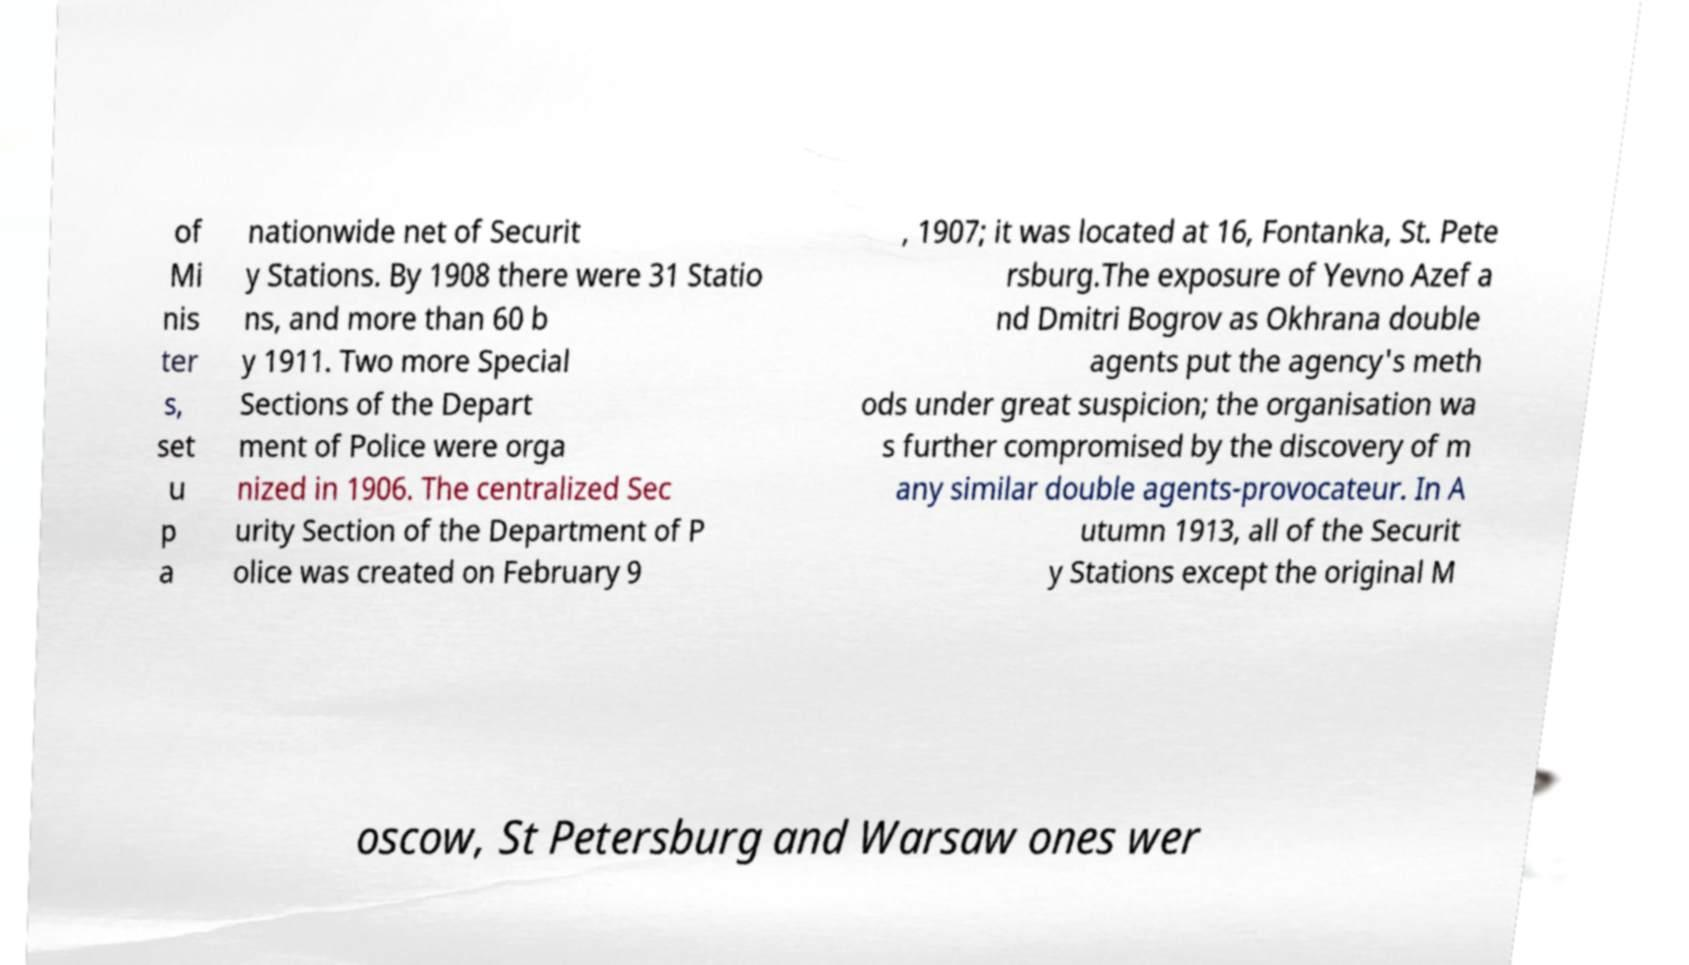Could you assist in decoding the text presented in this image and type it out clearly? of Mi nis ter s, set u p a nationwide net of Securit y Stations. By 1908 there were 31 Statio ns, and more than 60 b y 1911. Two more Special Sections of the Depart ment of Police were orga nized in 1906. The centralized Sec urity Section of the Department of P olice was created on February 9 , 1907; it was located at 16, Fontanka, St. Pete rsburg.The exposure of Yevno Azef a nd Dmitri Bogrov as Okhrana double agents put the agency's meth ods under great suspicion; the organisation wa s further compromised by the discovery of m any similar double agents-provocateur. In A utumn 1913, all of the Securit y Stations except the original M oscow, St Petersburg and Warsaw ones wer 